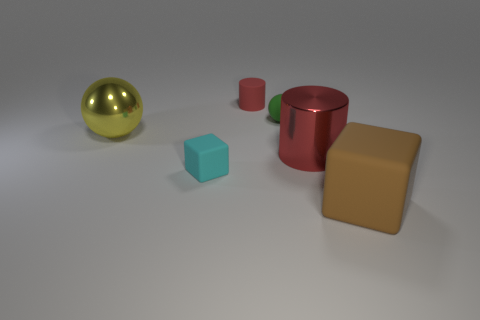Add 3 red rubber cylinders. How many objects exist? 9 Subtract all yellow blocks. How many green spheres are left? 1 Subtract all big green balls. Subtract all large red things. How many objects are left? 5 Add 2 rubber objects. How many rubber objects are left? 6 Add 6 small cyan shiny cylinders. How many small cyan shiny cylinders exist? 6 Subtract 0 gray cubes. How many objects are left? 6 Subtract all balls. How many objects are left? 4 Subtract 2 balls. How many balls are left? 0 Subtract all yellow spheres. Subtract all blue cubes. How many spheres are left? 1 